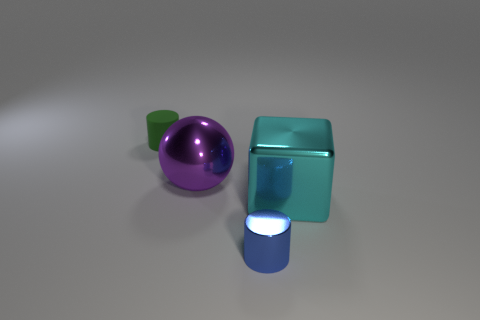Do the big metallic ball and the small object behind the large cyan metallic cube have the same color?
Offer a very short reply. No. How many purple objects are either blocks or large metallic spheres?
Offer a terse response. 1. What is the shape of the tiny blue metal thing?
Make the answer very short. Cylinder. How many other objects are the same shape as the cyan metallic thing?
Provide a short and direct response. 0. The cylinder right of the matte thing is what color?
Make the answer very short. Blue. Do the small blue thing and the green cylinder have the same material?
Your answer should be very brief. No. What number of things are metallic cylinders or cylinders on the right side of the green rubber cylinder?
Keep it short and to the point. 1. There is a large thing on the left side of the metal cube; what shape is it?
Provide a succinct answer. Sphere. There is a tiny cylinder in front of the purple metallic thing; does it have the same color as the rubber thing?
Offer a terse response. No. There is a blue metallic object in front of the green object; is its size the same as the matte cylinder?
Make the answer very short. Yes. 